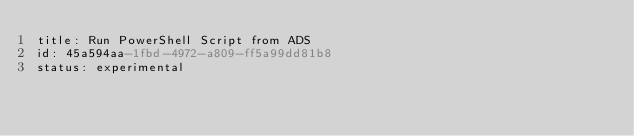Convert code to text. <code><loc_0><loc_0><loc_500><loc_500><_YAML_>title: Run PowerShell Script from ADS
id: 45a594aa-1fbd-4972-a809-ff5a99dd81b8
status: experimental</code> 